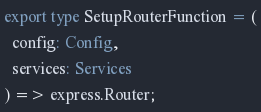<code> <loc_0><loc_0><loc_500><loc_500><_TypeScript_>export type SetupRouterFunction = (
  config: Config,
  services: Services
) => express.Router;
</code> 